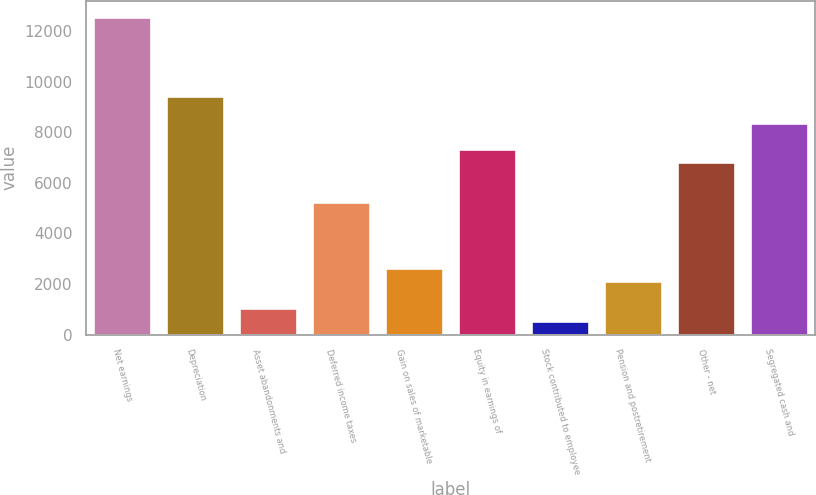Convert chart to OTSL. <chart><loc_0><loc_0><loc_500><loc_500><bar_chart><fcel>Net earnings<fcel>Depreciation<fcel>Asset abandonments and<fcel>Deferred income taxes<fcel>Gain on sales of marketable<fcel>Equity in earnings of<fcel>Stock contributed to employee<fcel>Pension and postretirement<fcel>Other - net<fcel>Segregated cash and<nl><fcel>12572.2<fcel>9432.4<fcel>1059.6<fcel>5246<fcel>2629.5<fcel>7339.2<fcel>536.3<fcel>2106.2<fcel>6815.9<fcel>8385.8<nl></chart> 